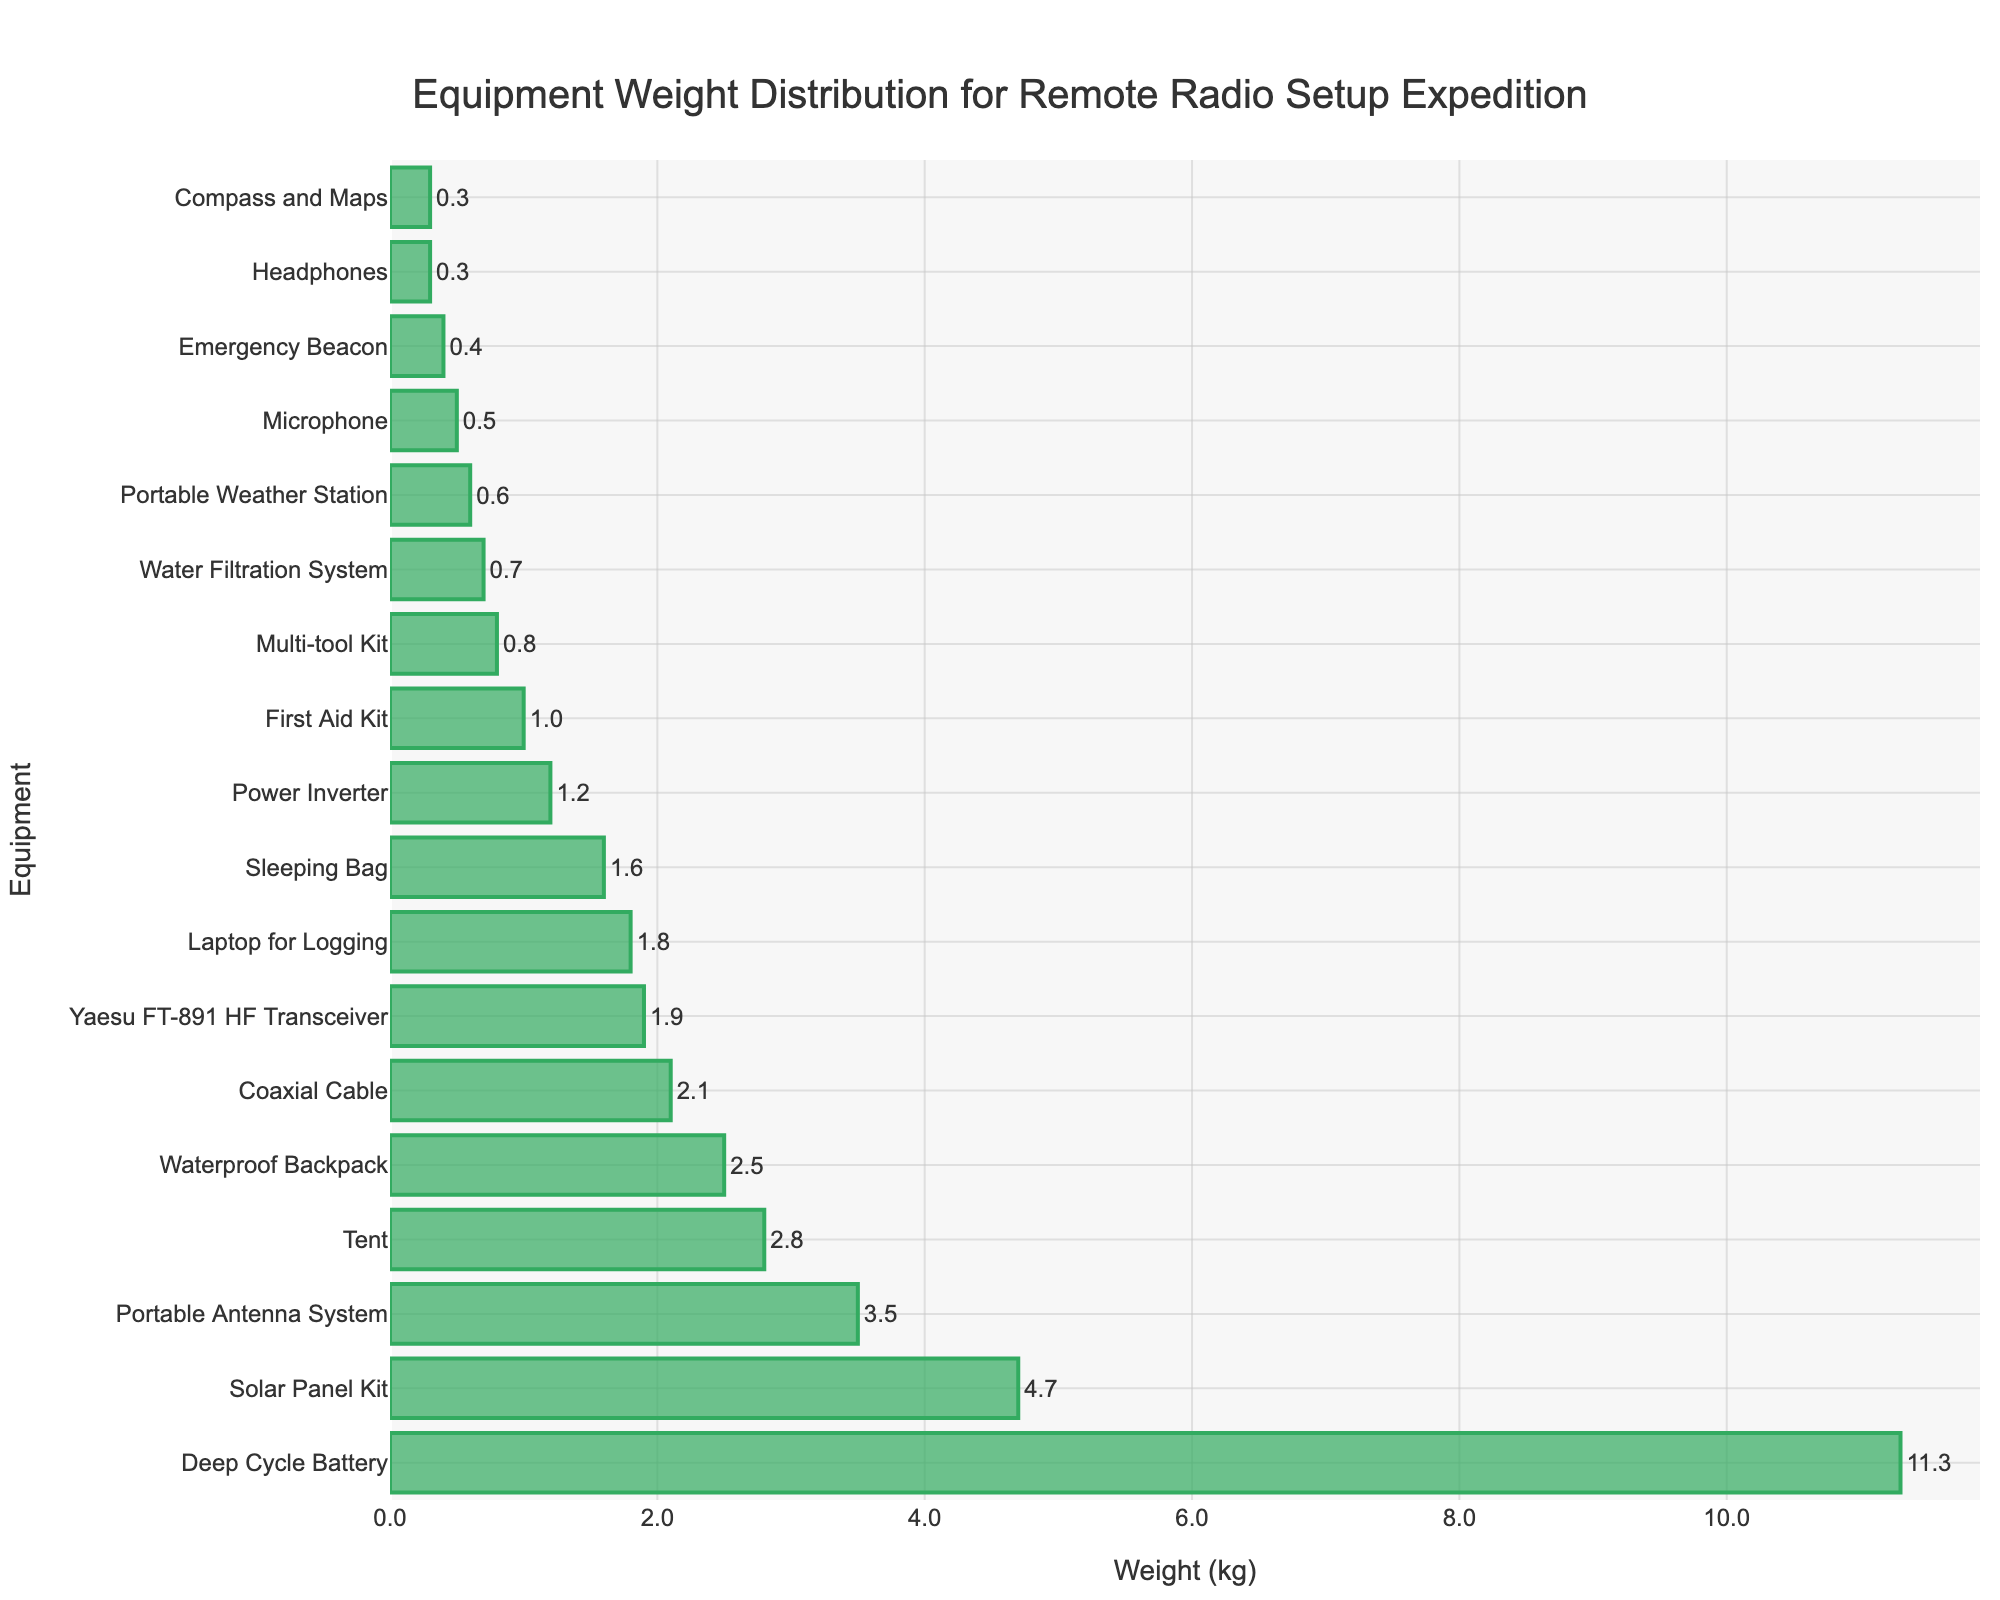Which equipment is the heaviest? The bar for the "Deep Cycle Battery" is the longest, indicating it has the highest weight.
Answer: Deep Cycle Battery What is the total weight of the Solar Panel Kit and the Tent combined? The weight of the Solar Panel Kit is 4.7 kg, and the weight of the Tent is 2.8 kg. Summing them gives 4.7 + 2.8 = 7.5 kg.
Answer: 7.5 kg Which item is lighter, the Compass and Maps or the Portable Weather Station? The bar for the Compass and Maps is shorter compared to the Portable Weather Station, indicating it has a lower weight.
Answer: Compass and Maps How much heavier is the Deep Cycle Battery than the Portable Antenna System? The weight of the Deep Cycle Battery is 11.3 kg, and the Portable Antenna System is 3.5 kg. Subtracting the weights gives 11.3 - 3.5 = 7.8 kg.
Answer: 7.8 kg What is the average weight of the Yaesu FT-891 HF Transceiver, Laptop for Logging, and Multi-tool Kit? The weights are 1.9 kg, 1.8 kg, and 0.8 kg, respectively. Summing them gives 1.9 + 1.8 + 0.8 = 4.5 kg. Dividing by 3 gives 4.5 / 3 = 1.5 kg.
Answer: 1.5 kg Which equipment item has a weight closest to 2 kg? The "Coaxial Cable" weighs 2.1 kg, which is the closest to 2 kg among the bars.
Answer: Coaxial Cable Is the Sleeping Bag heavier or lighter than the Waterproof Backpack? The bar for the Waterproof Backpack is longer than the Sleeping Bag, indicating it has a higher weight.
Answer: Lighter What is the combined weight of all the equipment items that weigh less than 1 kg? The weights are: Headphones (0.3 kg), Microphone (0.5 kg), Multi-tool Kit (0.8 kg), Emergency Beacon (0.4 kg), Compass and Maps (0.3 kg), and Portable Weather Station (0.6 kg). Summing them up gives 0.3 + 0.5 + 0.8 + 0.4 + 0.3 + 0.6 = 2.9 kg.
Answer: 2.9 kg How much more does the Tent weigh compared to the Sleeping Bag? The weight of the Tent is 2.8 kg and the Sleeping Bag is 1.6 kg. Subtracting the weights gives 2.8 - 1.6 = 1.2 kg.
Answer: 1.2 kg What is the weight of the least heavy equipment? The shortest bar belongs to the "Compass and Maps," which has a weight of 0.3 kg.
Answer: 0.3 kg 